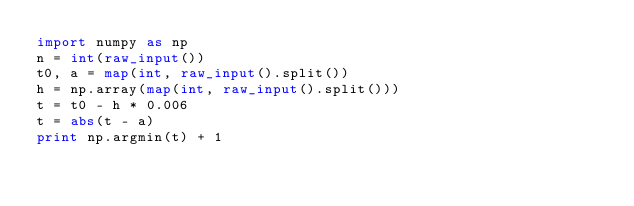<code> <loc_0><loc_0><loc_500><loc_500><_Python_>import numpy as np
n = int(raw_input())
t0, a = map(int, raw_input().split())
h = np.array(map(int, raw_input().split()))
t = t0 - h * 0.006
t = abs(t - a)
print np.argmin(t) + 1</code> 